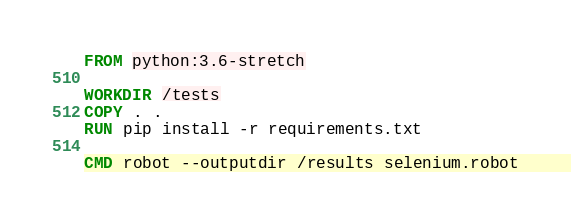Convert code to text. <code><loc_0><loc_0><loc_500><loc_500><_Dockerfile_>FROM python:3.6-stretch

WORKDIR /tests
COPY . .
RUN pip install -r requirements.txt

CMD robot --outputdir /results selenium.robot
</code> 